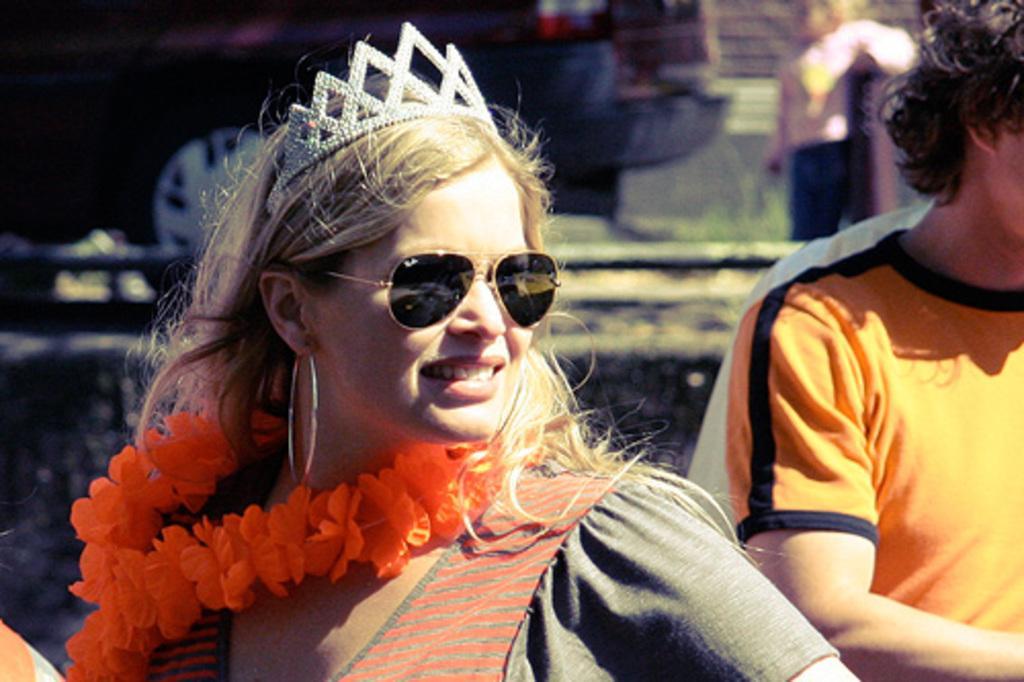How would you summarize this image in a sentence or two? In this picture we can see a woman wore a crown, goggles, garland and smiling and beside her we can see a person and at the back of them we can see a vehicle and a child standing on the ground. 